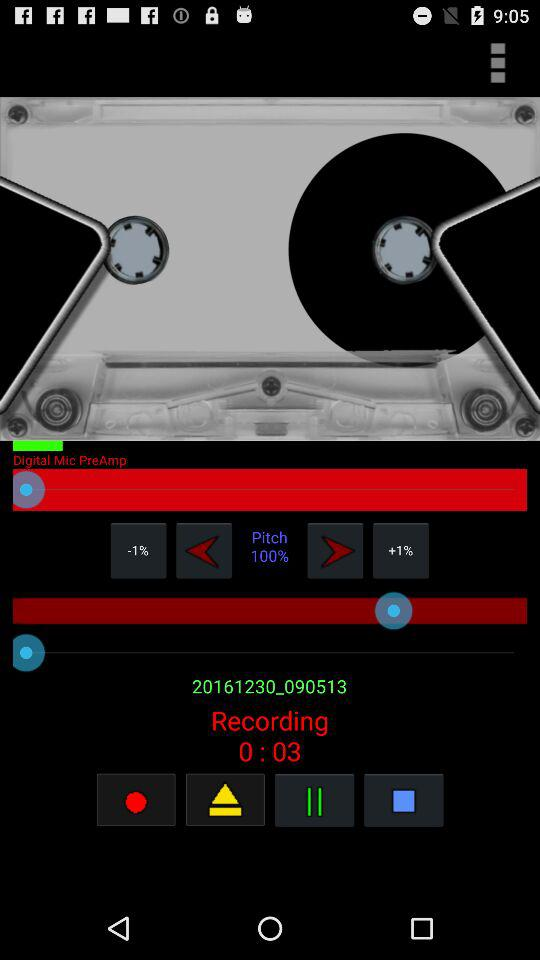How long has the recording been going on for?
Answer the question using a single word or phrase. 0:03 